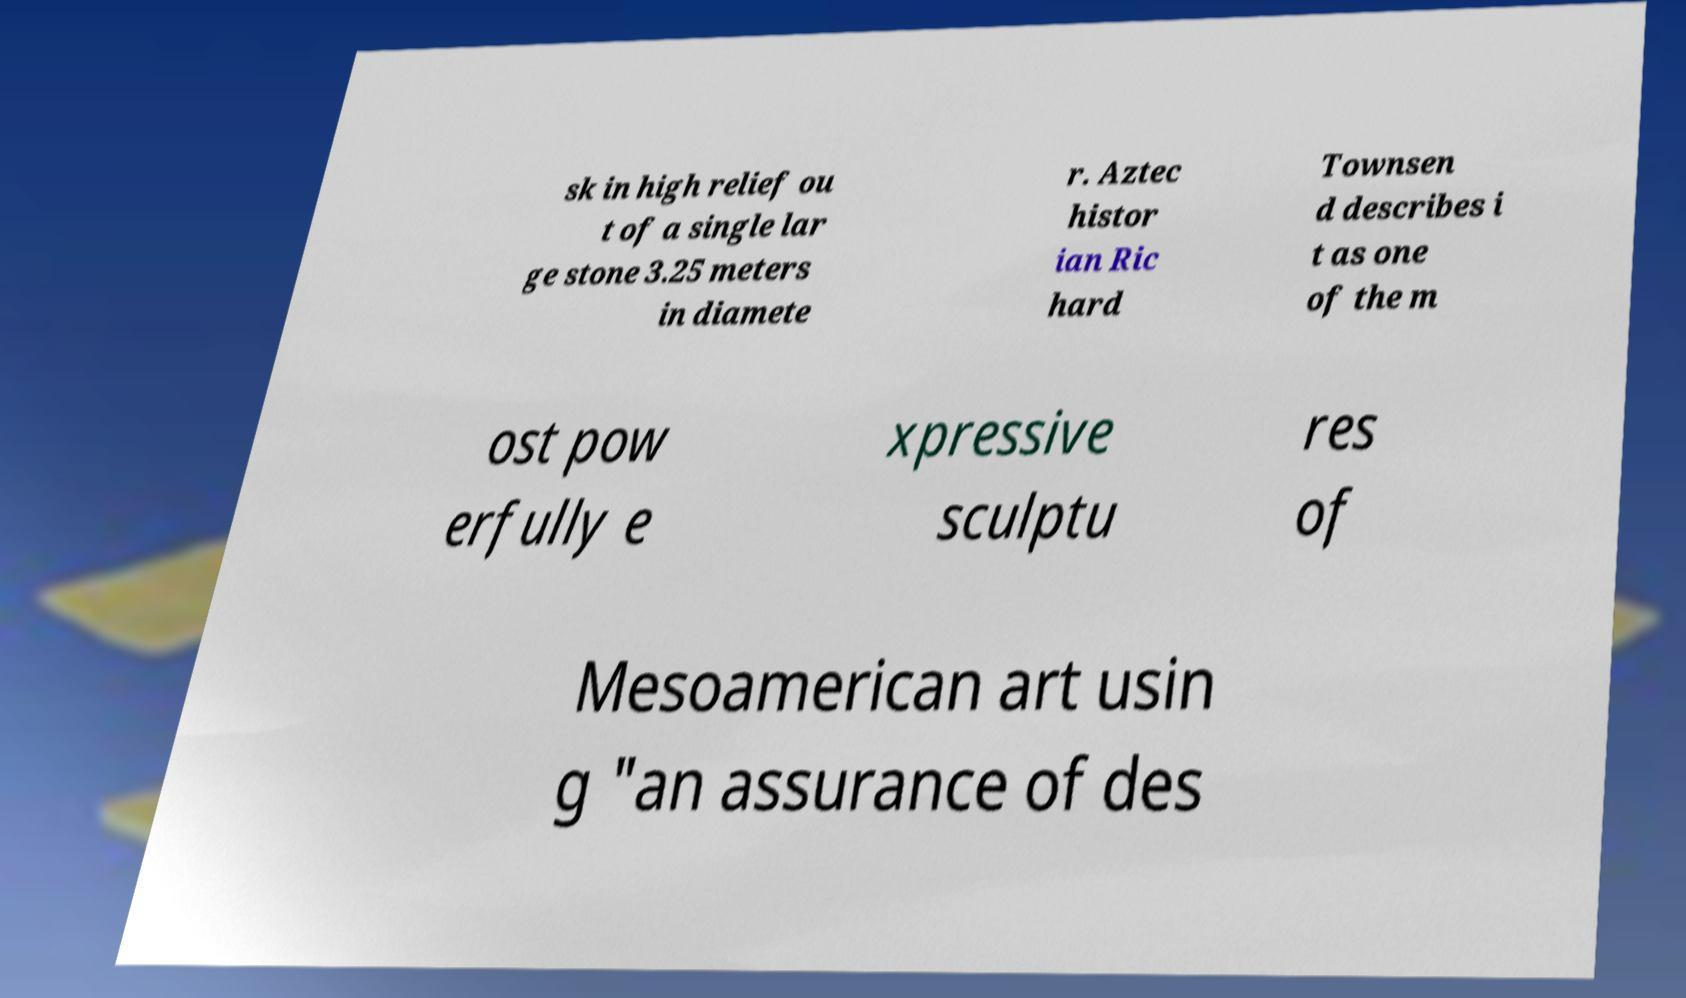Can you accurately transcribe the text from the provided image for me? sk in high relief ou t of a single lar ge stone 3.25 meters in diamete r. Aztec histor ian Ric hard Townsen d describes i t as one of the m ost pow erfully e xpressive sculptu res of Mesoamerican art usin g "an assurance of des 